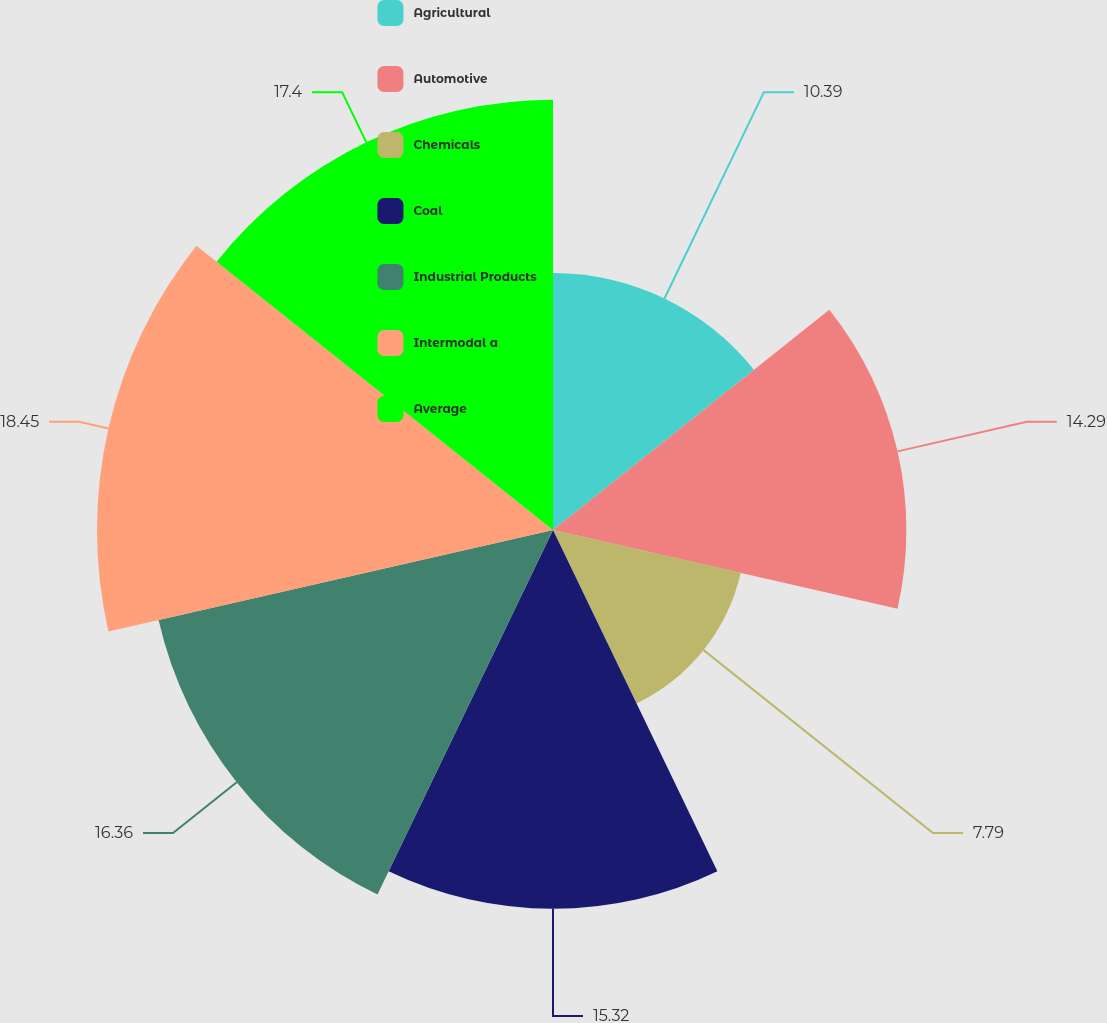Convert chart to OTSL. <chart><loc_0><loc_0><loc_500><loc_500><pie_chart><fcel>Agricultural<fcel>Automotive<fcel>Chemicals<fcel>Coal<fcel>Industrial Products<fcel>Intermodal a<fcel>Average<nl><fcel>10.39%<fcel>14.29%<fcel>7.79%<fcel>15.32%<fcel>16.36%<fcel>18.44%<fcel>17.4%<nl></chart> 